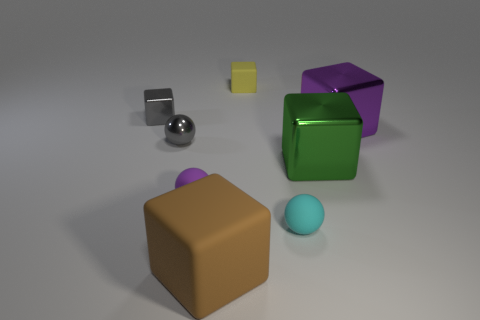Subtract all purple cubes. How many cubes are left? 4 Subtract all green metallic blocks. How many blocks are left? 4 Subtract all blue cubes. Subtract all cyan cylinders. How many cubes are left? 5 Add 1 metal objects. How many objects exist? 9 Subtract all spheres. How many objects are left? 5 Add 7 big red spheres. How many big red spheres exist? 7 Subtract 0 yellow cylinders. How many objects are left? 8 Subtract all blue rubber spheres. Subtract all gray metal spheres. How many objects are left? 7 Add 7 large purple metallic blocks. How many large purple metallic blocks are left? 8 